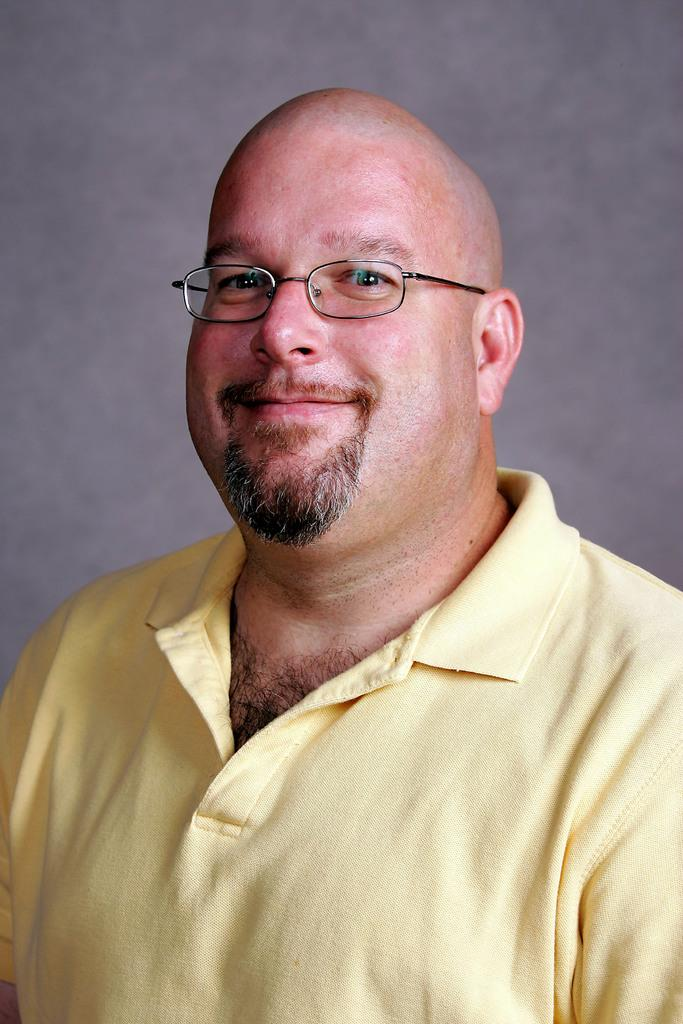Who is present in the image? There is a man in the image. What is the man wearing on his upper body? The man is wearing a yellow t-shirt. Are there any accessories visible on the man? Yes, the man is wearing glasses. What is the man's facial expression in the image? The man is smiling. What type of addition is being made to the man's house in the image? There is no mention of a house or any additions being made in the image. The image only features a man wearing a yellow t-shirt, glasses, and smiling. 